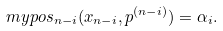Convert formula to latex. <formula><loc_0><loc_0><loc_500><loc_500>\ m y p o s _ { n - i } ( x _ { n - i } , p ^ { ( n - i ) } ) = \alpha _ { i } .</formula> 